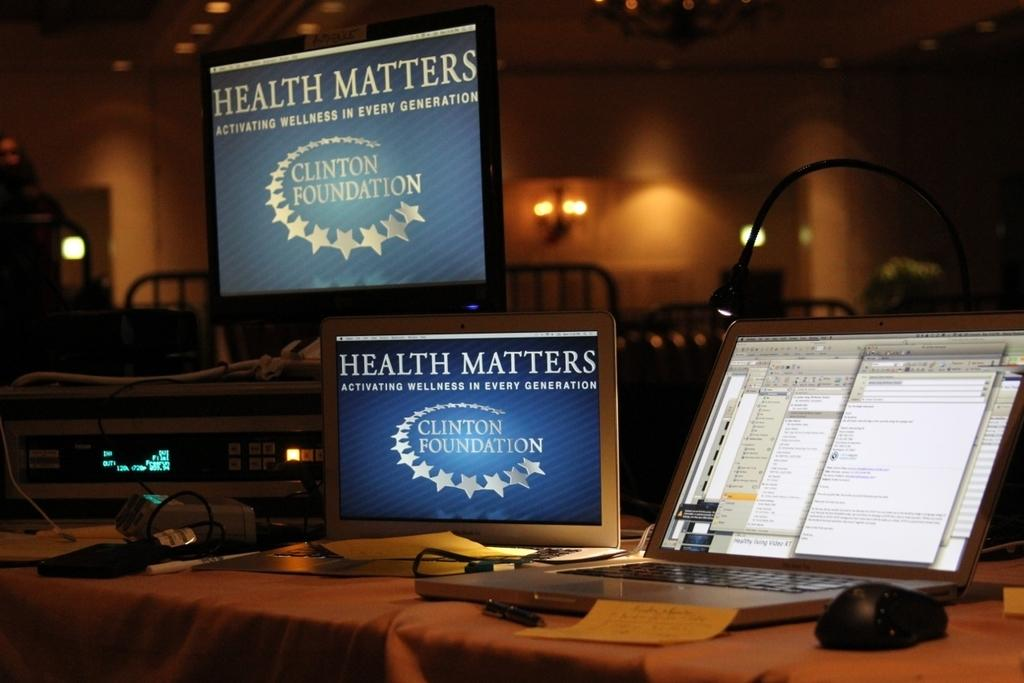<image>
Share a concise interpretation of the image provided. Health Matters is displayed on to of several computer screens in a dark room 